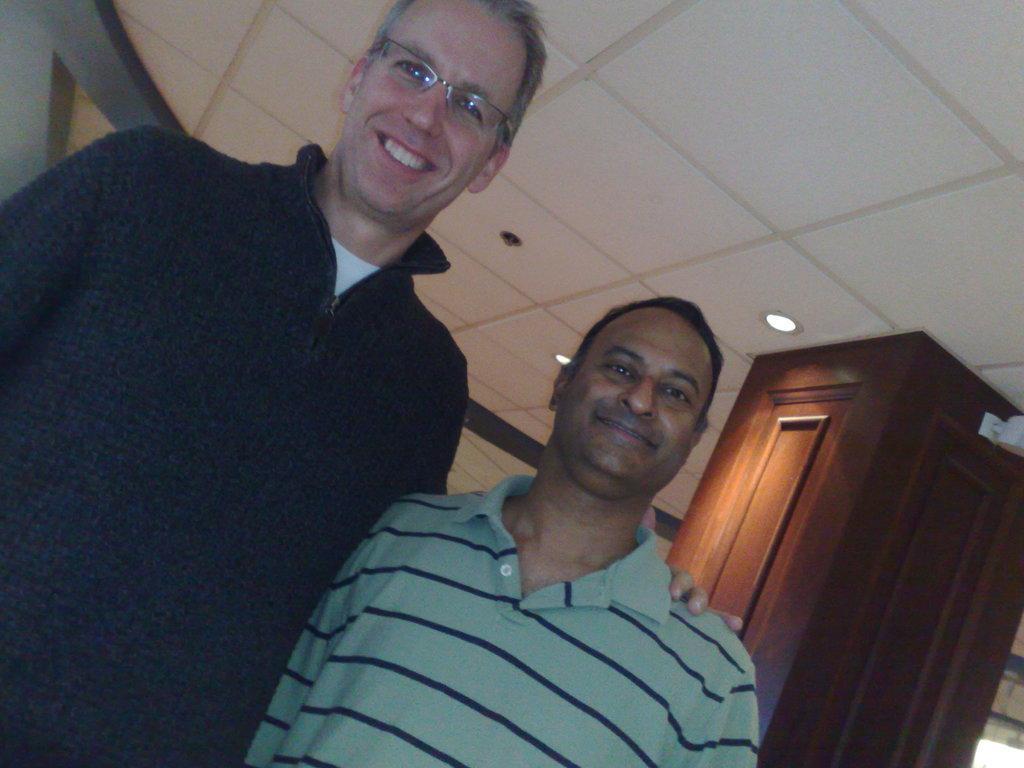Please provide a concise description of this image. In this picture there are men in the center of the image and there is a wooden pillar and lamps in the background area of the image. 